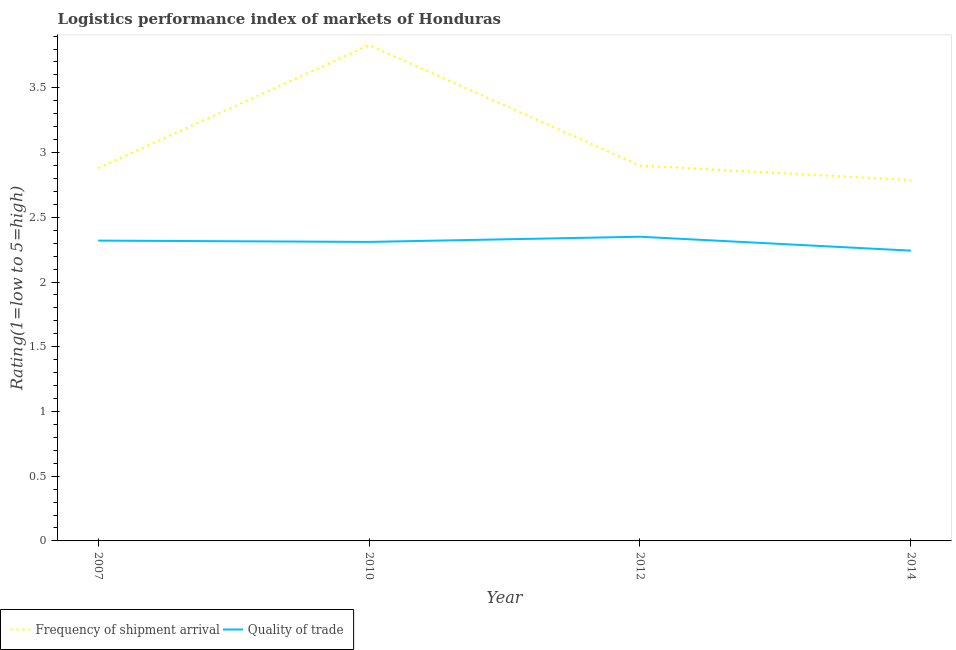How many different coloured lines are there?
Keep it short and to the point. 2. Does the line corresponding to lpi of frequency of shipment arrival intersect with the line corresponding to lpi quality of trade?
Provide a short and direct response. No. Is the number of lines equal to the number of legend labels?
Ensure brevity in your answer.  Yes. What is the lpi quality of trade in 2012?
Offer a terse response. 2.35. Across all years, what is the maximum lpi quality of trade?
Your answer should be compact. 2.35. Across all years, what is the minimum lpi of frequency of shipment arrival?
Offer a very short reply. 2.79. In which year was the lpi of frequency of shipment arrival maximum?
Ensure brevity in your answer.  2010. In which year was the lpi of frequency of shipment arrival minimum?
Provide a short and direct response. 2014. What is the total lpi quality of trade in the graph?
Keep it short and to the point. 9.22. What is the difference between the lpi quality of trade in 2007 and that in 2012?
Ensure brevity in your answer.  -0.03. What is the difference between the lpi quality of trade in 2012 and the lpi of frequency of shipment arrival in 2014?
Offer a very short reply. -0.44. What is the average lpi of frequency of shipment arrival per year?
Your answer should be very brief. 3.1. In the year 2007, what is the difference between the lpi quality of trade and lpi of frequency of shipment arrival?
Keep it short and to the point. -0.56. What is the ratio of the lpi of frequency of shipment arrival in 2012 to that in 2014?
Your answer should be very brief. 1.04. Is the lpi quality of trade in 2010 less than that in 2014?
Provide a succinct answer. No. Is the difference between the lpi quality of trade in 2012 and 2014 greater than the difference between the lpi of frequency of shipment arrival in 2012 and 2014?
Your response must be concise. No. What is the difference between the highest and the second highest lpi of frequency of shipment arrival?
Keep it short and to the point. 0.93. What is the difference between the highest and the lowest lpi of frequency of shipment arrival?
Make the answer very short. 1.04. In how many years, is the lpi quality of trade greater than the average lpi quality of trade taken over all years?
Offer a terse response. 3. Does the lpi of frequency of shipment arrival monotonically increase over the years?
Ensure brevity in your answer.  No. How many years are there in the graph?
Give a very brief answer. 4. How are the legend labels stacked?
Give a very brief answer. Horizontal. What is the title of the graph?
Offer a terse response. Logistics performance index of markets of Honduras. Does "Secondary Education" appear as one of the legend labels in the graph?
Give a very brief answer. No. What is the label or title of the Y-axis?
Provide a short and direct response. Rating(1=low to 5=high). What is the Rating(1=low to 5=high) in Frequency of shipment arrival in 2007?
Your answer should be compact. 2.88. What is the Rating(1=low to 5=high) of Quality of trade in 2007?
Your response must be concise. 2.32. What is the Rating(1=low to 5=high) of Frequency of shipment arrival in 2010?
Offer a very short reply. 3.83. What is the Rating(1=low to 5=high) of Quality of trade in 2010?
Offer a terse response. 2.31. What is the Rating(1=low to 5=high) in Quality of trade in 2012?
Make the answer very short. 2.35. What is the Rating(1=low to 5=high) of Frequency of shipment arrival in 2014?
Give a very brief answer. 2.79. What is the Rating(1=low to 5=high) of Quality of trade in 2014?
Offer a terse response. 2.24. Across all years, what is the maximum Rating(1=low to 5=high) in Frequency of shipment arrival?
Your answer should be very brief. 3.83. Across all years, what is the maximum Rating(1=low to 5=high) of Quality of trade?
Ensure brevity in your answer.  2.35. Across all years, what is the minimum Rating(1=low to 5=high) in Frequency of shipment arrival?
Provide a short and direct response. 2.79. Across all years, what is the minimum Rating(1=low to 5=high) in Quality of trade?
Ensure brevity in your answer.  2.24. What is the total Rating(1=low to 5=high) of Frequency of shipment arrival in the graph?
Your answer should be very brief. 12.4. What is the total Rating(1=low to 5=high) in Quality of trade in the graph?
Your answer should be very brief. 9.22. What is the difference between the Rating(1=low to 5=high) in Frequency of shipment arrival in 2007 and that in 2010?
Offer a very short reply. -0.95. What is the difference between the Rating(1=low to 5=high) in Frequency of shipment arrival in 2007 and that in 2012?
Give a very brief answer. -0.02. What is the difference between the Rating(1=low to 5=high) of Quality of trade in 2007 and that in 2012?
Make the answer very short. -0.03. What is the difference between the Rating(1=low to 5=high) in Frequency of shipment arrival in 2007 and that in 2014?
Make the answer very short. 0.09. What is the difference between the Rating(1=low to 5=high) in Quality of trade in 2007 and that in 2014?
Ensure brevity in your answer.  0.08. What is the difference between the Rating(1=low to 5=high) of Quality of trade in 2010 and that in 2012?
Keep it short and to the point. -0.04. What is the difference between the Rating(1=low to 5=high) of Frequency of shipment arrival in 2010 and that in 2014?
Your response must be concise. 1.04. What is the difference between the Rating(1=low to 5=high) in Quality of trade in 2010 and that in 2014?
Provide a short and direct response. 0.07. What is the difference between the Rating(1=low to 5=high) of Frequency of shipment arrival in 2012 and that in 2014?
Your answer should be very brief. 0.11. What is the difference between the Rating(1=low to 5=high) of Quality of trade in 2012 and that in 2014?
Give a very brief answer. 0.11. What is the difference between the Rating(1=low to 5=high) of Frequency of shipment arrival in 2007 and the Rating(1=low to 5=high) of Quality of trade in 2010?
Your answer should be compact. 0.57. What is the difference between the Rating(1=low to 5=high) in Frequency of shipment arrival in 2007 and the Rating(1=low to 5=high) in Quality of trade in 2012?
Your response must be concise. 0.53. What is the difference between the Rating(1=low to 5=high) of Frequency of shipment arrival in 2007 and the Rating(1=low to 5=high) of Quality of trade in 2014?
Give a very brief answer. 0.64. What is the difference between the Rating(1=low to 5=high) of Frequency of shipment arrival in 2010 and the Rating(1=low to 5=high) of Quality of trade in 2012?
Your response must be concise. 1.48. What is the difference between the Rating(1=low to 5=high) in Frequency of shipment arrival in 2010 and the Rating(1=low to 5=high) in Quality of trade in 2014?
Offer a terse response. 1.59. What is the difference between the Rating(1=low to 5=high) of Frequency of shipment arrival in 2012 and the Rating(1=low to 5=high) of Quality of trade in 2014?
Give a very brief answer. 0.66. What is the average Rating(1=low to 5=high) in Frequency of shipment arrival per year?
Keep it short and to the point. 3.1. What is the average Rating(1=low to 5=high) of Quality of trade per year?
Ensure brevity in your answer.  2.31. In the year 2007, what is the difference between the Rating(1=low to 5=high) of Frequency of shipment arrival and Rating(1=low to 5=high) of Quality of trade?
Your answer should be compact. 0.56. In the year 2010, what is the difference between the Rating(1=low to 5=high) of Frequency of shipment arrival and Rating(1=low to 5=high) of Quality of trade?
Ensure brevity in your answer.  1.52. In the year 2012, what is the difference between the Rating(1=low to 5=high) of Frequency of shipment arrival and Rating(1=low to 5=high) of Quality of trade?
Provide a short and direct response. 0.55. In the year 2014, what is the difference between the Rating(1=low to 5=high) of Frequency of shipment arrival and Rating(1=low to 5=high) of Quality of trade?
Your response must be concise. 0.55. What is the ratio of the Rating(1=low to 5=high) in Frequency of shipment arrival in 2007 to that in 2010?
Provide a succinct answer. 0.75. What is the ratio of the Rating(1=low to 5=high) of Frequency of shipment arrival in 2007 to that in 2012?
Ensure brevity in your answer.  0.99. What is the ratio of the Rating(1=low to 5=high) of Quality of trade in 2007 to that in 2012?
Provide a short and direct response. 0.99. What is the ratio of the Rating(1=low to 5=high) in Frequency of shipment arrival in 2007 to that in 2014?
Ensure brevity in your answer.  1.03. What is the ratio of the Rating(1=low to 5=high) in Quality of trade in 2007 to that in 2014?
Your answer should be compact. 1.03. What is the ratio of the Rating(1=low to 5=high) of Frequency of shipment arrival in 2010 to that in 2012?
Your answer should be very brief. 1.32. What is the ratio of the Rating(1=low to 5=high) in Frequency of shipment arrival in 2010 to that in 2014?
Ensure brevity in your answer.  1.37. What is the ratio of the Rating(1=low to 5=high) of Quality of trade in 2010 to that in 2014?
Provide a succinct answer. 1.03. What is the ratio of the Rating(1=low to 5=high) of Frequency of shipment arrival in 2012 to that in 2014?
Ensure brevity in your answer.  1.04. What is the ratio of the Rating(1=low to 5=high) in Quality of trade in 2012 to that in 2014?
Provide a short and direct response. 1.05. What is the difference between the highest and the second highest Rating(1=low to 5=high) of Frequency of shipment arrival?
Provide a short and direct response. 0.93. What is the difference between the highest and the second highest Rating(1=low to 5=high) of Quality of trade?
Provide a short and direct response. 0.03. What is the difference between the highest and the lowest Rating(1=low to 5=high) in Frequency of shipment arrival?
Ensure brevity in your answer.  1.04. What is the difference between the highest and the lowest Rating(1=low to 5=high) of Quality of trade?
Your response must be concise. 0.11. 